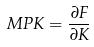<formula> <loc_0><loc_0><loc_500><loc_500>M P K = \frac { \partial F } { \partial K }</formula> 